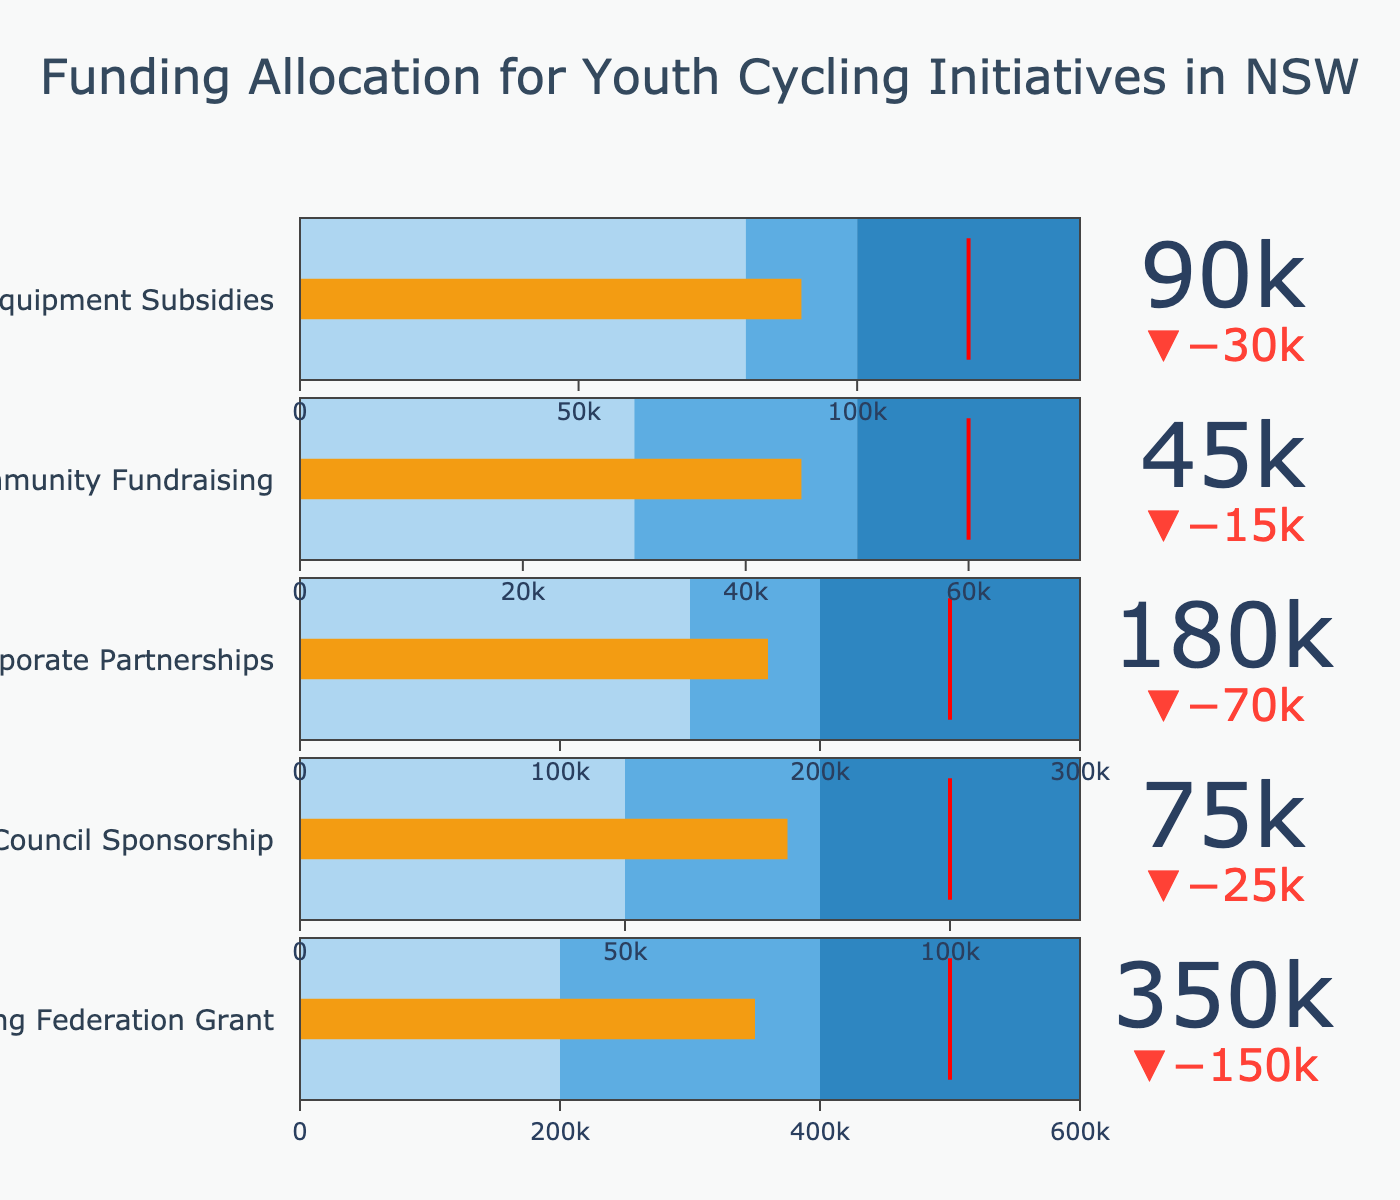What is the title of the figure? The title is located at the top center of the figure and is written in a larger font size, which helps viewers quickly identify the main topic of the chart.
Answer: Funding Allocation for Youth Cycling Initiatives in NSW Which category has the highest funding actual value? To determine this, we compare the 'Actual' values for all categories. The category with the largest 'Actual' value is "NSW Cycling Federation Grant" with 350,000 units.
Answer: NSW Cycling Federation Grant How does the actual value for Local Council Sponsorship compare to its target value? By checking the 'Actual' value (75,000) against the 'Target' value (100,000), we see that the 'Actual' is 25,000 units less than the 'Target'.
Answer: 75,000 is less than 100,000 What is the range of values for Equipment Subsidies? The range for this category can be found next to the horizontal bar. It extends from 0 to "Range3", which is 140,000 units.
Answer: 0 to 140,000 Which category achieved its target value the most closely? To find this, look for the smallest difference between 'Actual' and 'Target' values. The 'Corporate Partnerships' category has 'Actual' of 180,000 and 'Target' of 250,000, hence a difference of 70,000 units, which is the minimum when compared to other categories.
Answer: Corporate Partnerships How much more funding would Community Fundraising need to reach its target? To find out, subtract the 'Actual' value (45,000) from the 'Target' value (60,000). The difference is 15,000 units.
Answer: 15,000 Which categories fall short of their range3 values? Category 'Actual' values need to be compared to 'Range3' values. All categories except "NSW Cycling Federation Grant" and "Equipment Subsidies" fall short of their Range3 values.
Answer: Local Council Sponsorship, Corporate Partnerships, Community Fundraising What are the funding values in the 'steps' range for Corporate Partnerships? 'Steps' indicate progressive ranges of funding. For Corporate Partnerships, steps are: first [0 to 150,000], second [150,000 to 200,000], and third [200,000 to 300,000].
Answer: 0 to 150,000, 150,000 to 200,000, 200,000 to 300,000 How much more funding did Local Council Sponsorship need to exceed its second range (Range2)? 'Actual' value is 75,000, while 'Range2' value is 80,000. Subtracting these, Local Council Sponsorship needed 5,000 more units to exceed its second range.
Answer: 5,000 